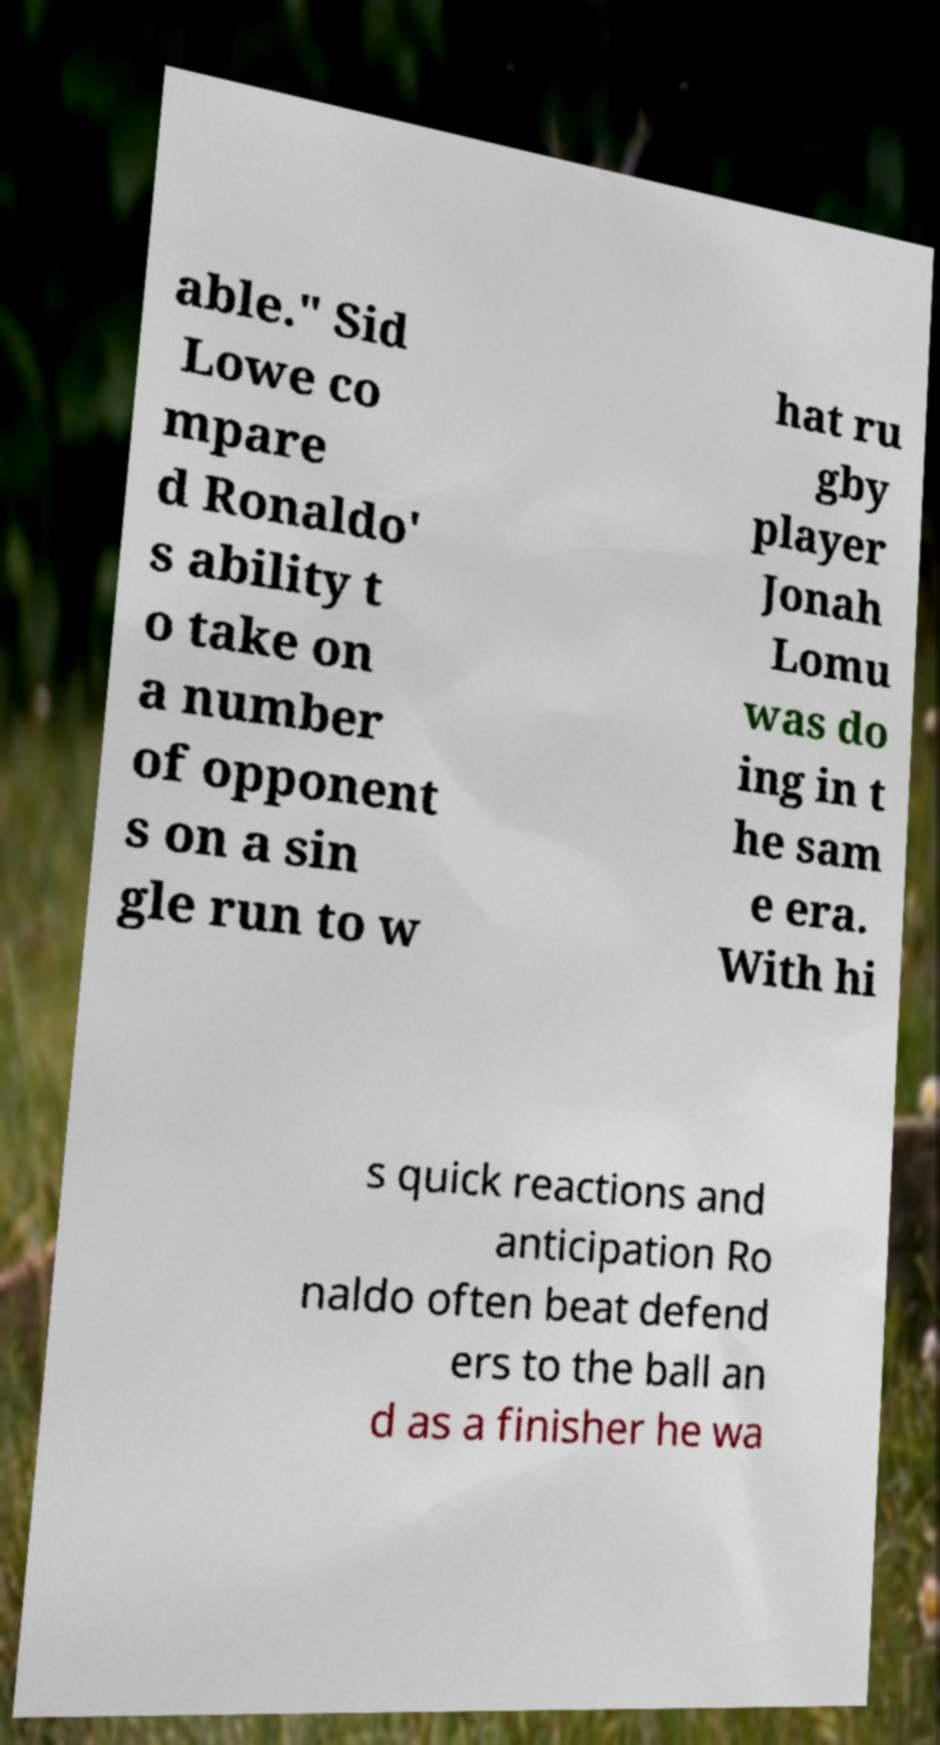For documentation purposes, I need the text within this image transcribed. Could you provide that? able." Sid Lowe co mpare d Ronaldo' s ability t o take on a number of opponent s on a sin gle run to w hat ru gby player Jonah Lomu was do ing in t he sam e era. With hi s quick reactions and anticipation Ro naldo often beat defend ers to the ball an d as a finisher he wa 